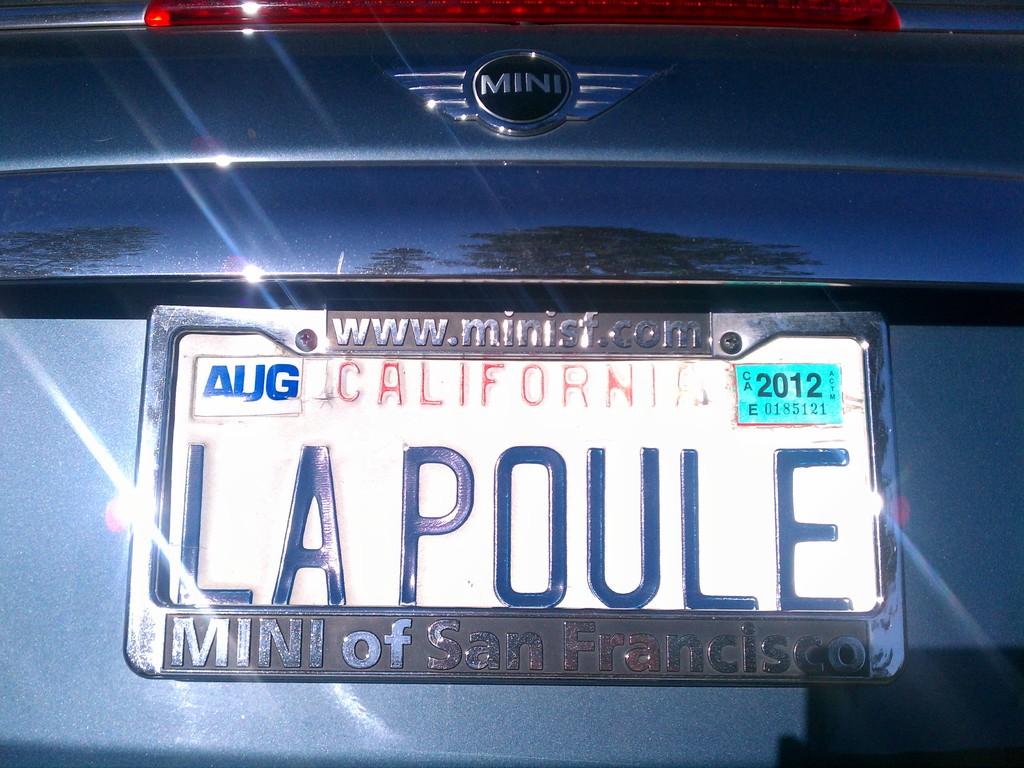What state was this licenses plate issues?
Your answer should be very brief. California. What year does the tag expire?
Your answer should be very brief. 2012. 